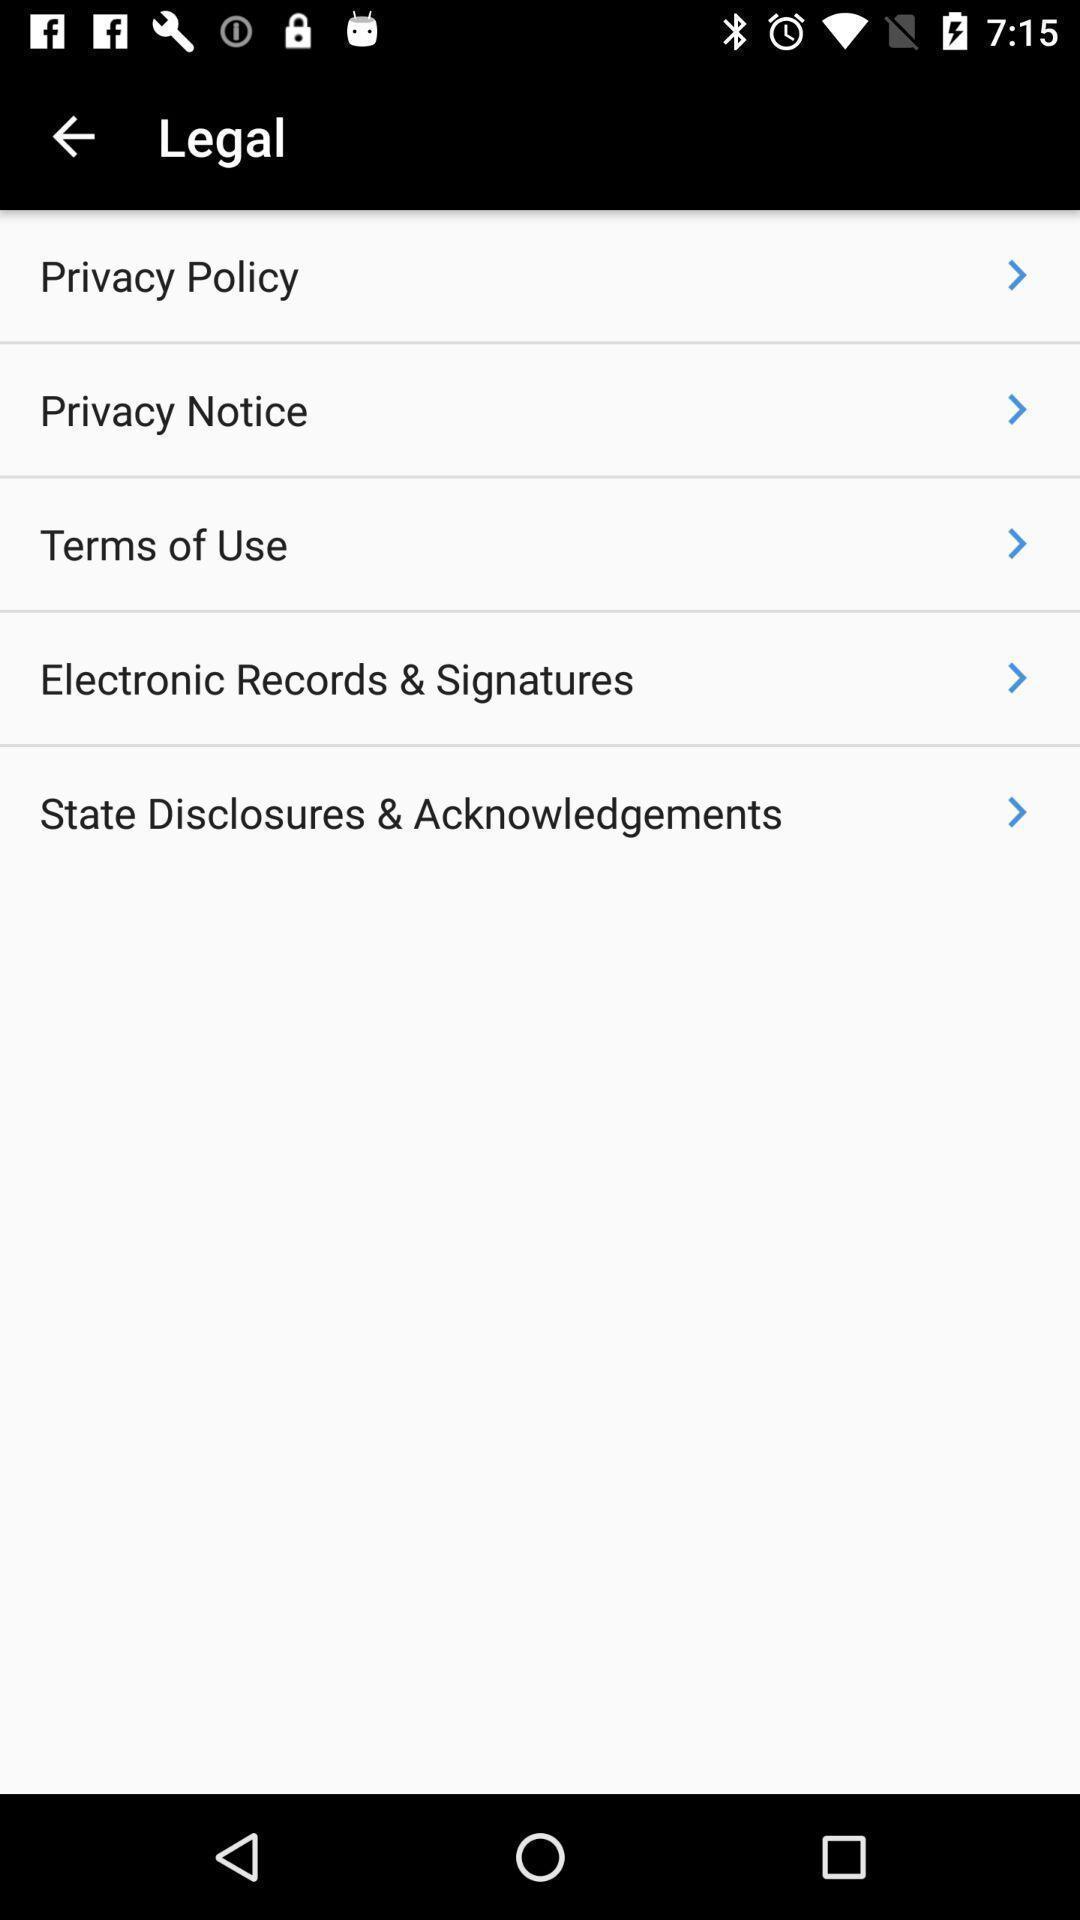Describe the content in this image. Screen showing various legal settings. 